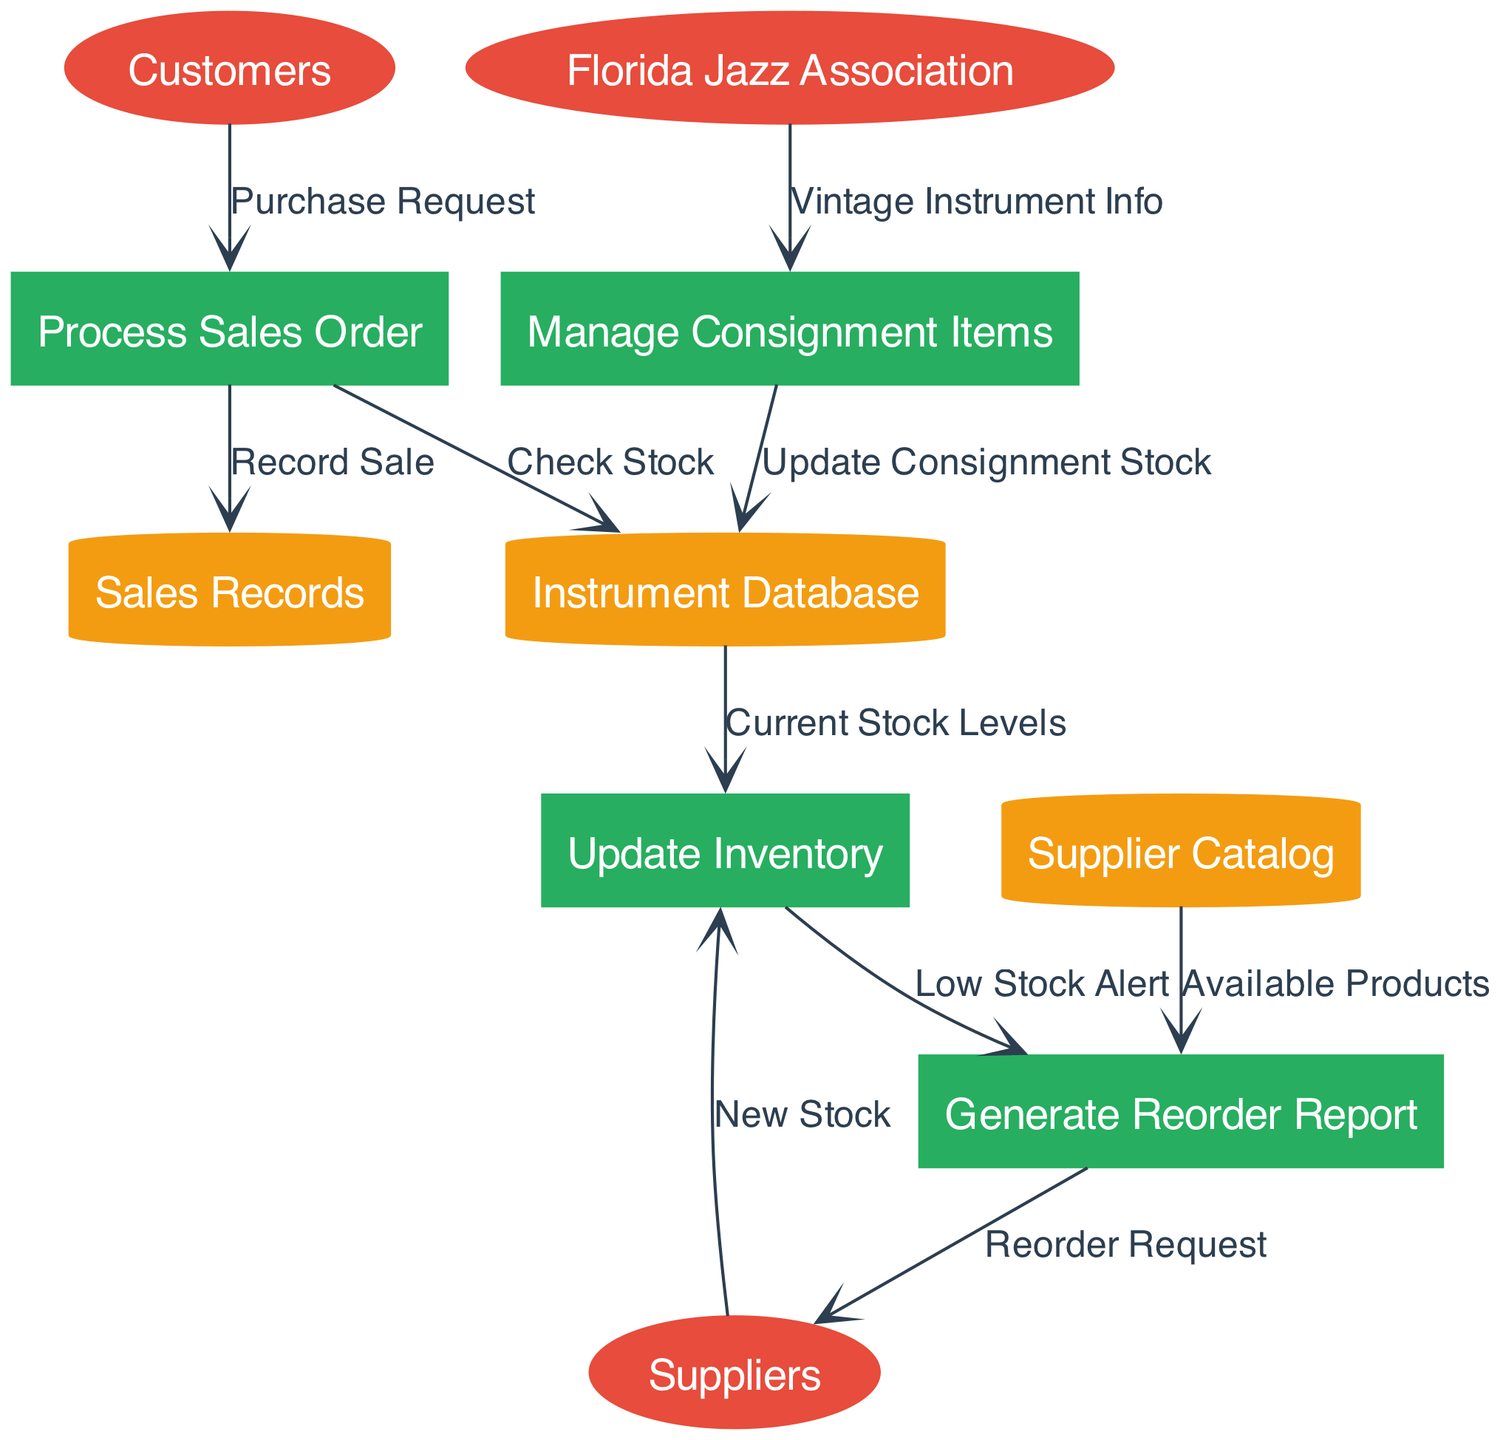What are the external entities in the diagram? The external entities listed in the diagram include Customers, Suppliers, and Florida Jazz Association. Based on the provided data, these entities are indicated as entities that interact with the inventory management system.
Answer: Customers, Suppliers, Florida Jazz Association How many processes are defined in the diagram? The diagram defines four processes: Process Sales Order, Update Inventory, Generate Reorder Report, and Manage Consignment Items. By counting the items listed in the "processes" section of the provided data, I arrive at this total.
Answer: 4 What data flow connects Customers to Process Sales Order? The data flow from Customers to Process Sales Order is labeled "Purchase Request". This information is specified in the "data_flows" section and provides a clear connection between these two components of the diagram.
Answer: Purchase Request Which process generates a reorder report? The process labeled "Generate Reorder Report" is responsible for creating reorder reports. Referring to the "processes" section of the data, it explicitly states the name of this process, indicating its specific function in inventory management.
Answer: Generate Reorder Report What data store is updated by the "Manage Consignment Items" process? The data store updated by the process "Manage Consignment Items" is the "Instrument Database." According to the data flow labeled "Update Consignment Stock," this process provides updated data to this specific store.
Answer: Instrument Database What is the label of the data flow from Suppliers to Update Inventory? The data flow from Suppliers to Update Inventory is labeled "New Stock." This label is inferred from the data_flow concerning the interaction between these two nodes, indicating the nature of the information passed.
Answer: New Stock Which external entity provides vintage instrument information? Florida Jazz Association provides vintage instrument information. The connection is established through the data flow labeled "Vintage Instrument Info" leading to the process "Manage Consignment Items," as indicated in the data provided.
Answer: Florida Jazz Association If there is a low stock alert, which report is generated next? If there is a low stock alert, the next report generated is the "Generate Reorder Report." This is shown through the flow from "Update Inventory" to "Generate Reorder Report" which is triggered by low stock levels.
Answer: Generate Reorder Report What is the first step when a customer makes a purchase request? The first step when a customer makes a purchase request is to "Process Sales Order." The data flow from Customers to Process Sales Order indicates this initial action required when a customer approaches the store.
Answer: Process Sales Order 